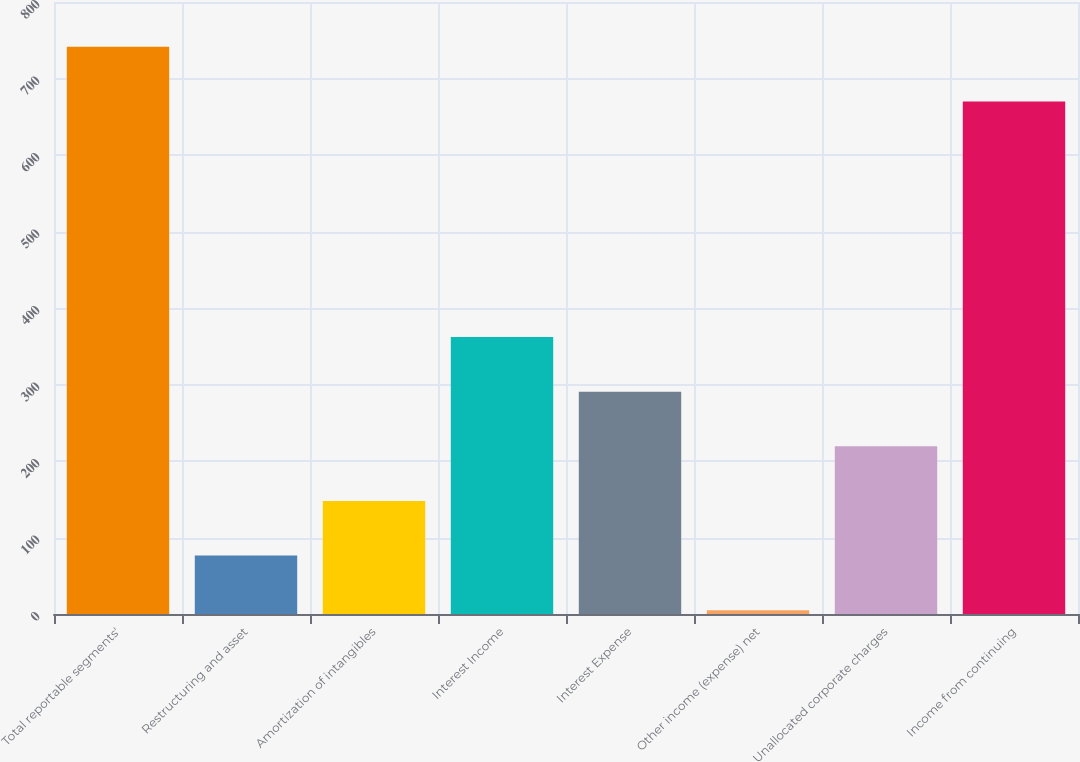Convert chart. <chart><loc_0><loc_0><loc_500><loc_500><bar_chart><fcel>Total reportable segments'<fcel>Restructuring and asset<fcel>Amortization of intangibles<fcel>Interest Income<fcel>Interest Expense<fcel>Other income (expense) net<fcel>Unallocated corporate charges<fcel>Income from continuing<nl><fcel>741.4<fcel>76.4<fcel>147.8<fcel>362<fcel>290.6<fcel>5<fcel>219.2<fcel>670<nl></chart> 